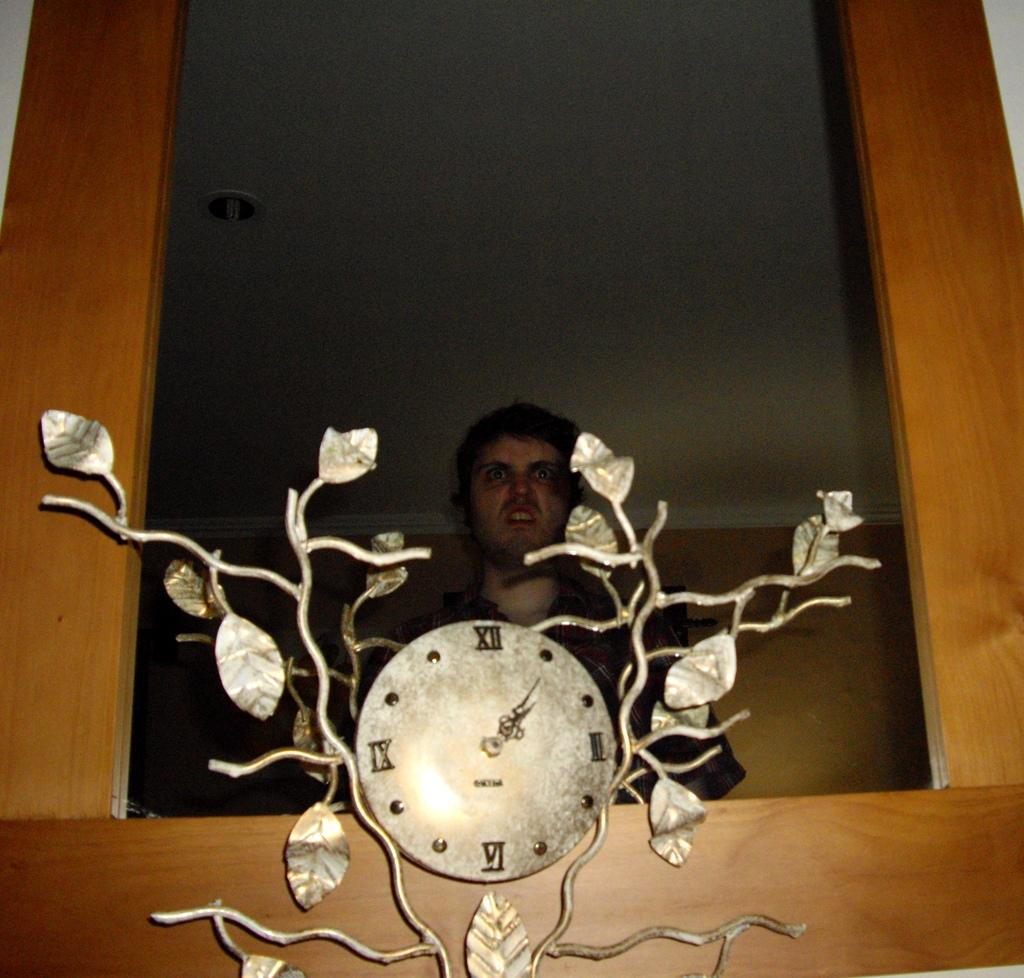<image>
Render a clear and concise summary of the photo. A man stands behind a decorative clock showing the time to be 1:05. 